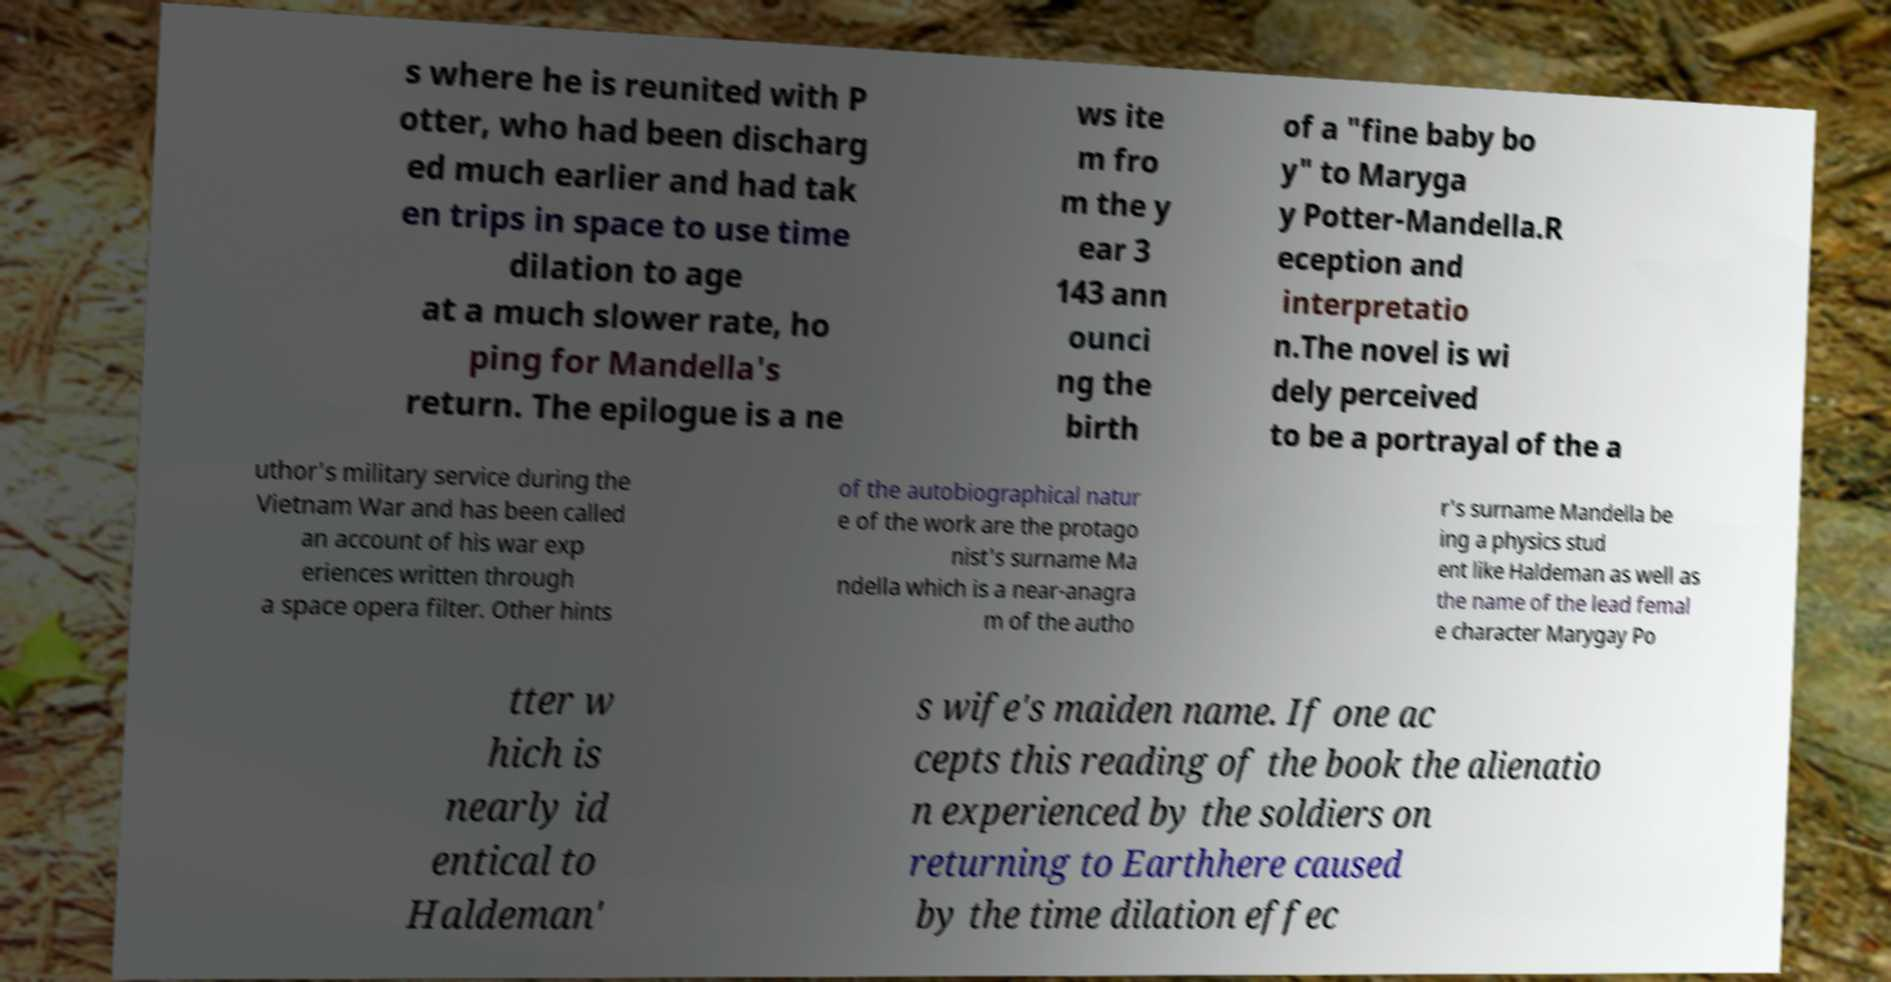I need the written content from this picture converted into text. Can you do that? s where he is reunited with P otter, who had been discharg ed much earlier and had tak en trips in space to use time dilation to age at a much slower rate, ho ping for Mandella's return. The epilogue is a ne ws ite m fro m the y ear 3 143 ann ounci ng the birth of a "fine baby bo y" to Maryga y Potter-Mandella.R eception and interpretatio n.The novel is wi dely perceived to be a portrayal of the a uthor's military service during the Vietnam War and has been called an account of his war exp eriences written through a space opera filter. Other hints of the autobiographical natur e of the work are the protago nist's surname Ma ndella which is a near-anagra m of the autho r's surname Mandella be ing a physics stud ent like Haldeman as well as the name of the lead femal e character Marygay Po tter w hich is nearly id entical to Haldeman' s wife's maiden name. If one ac cepts this reading of the book the alienatio n experienced by the soldiers on returning to Earthhere caused by the time dilation effec 